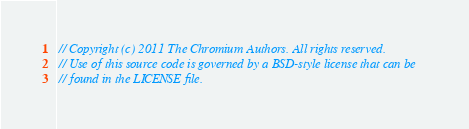Convert code to text. <code><loc_0><loc_0><loc_500><loc_500><_ObjectiveC_>// Copyright (c) 2011 The Chromium Authors. All rights reserved.
// Use of this source code is governed by a BSD-style license that can be
// found in the LICENSE file.
</code> 